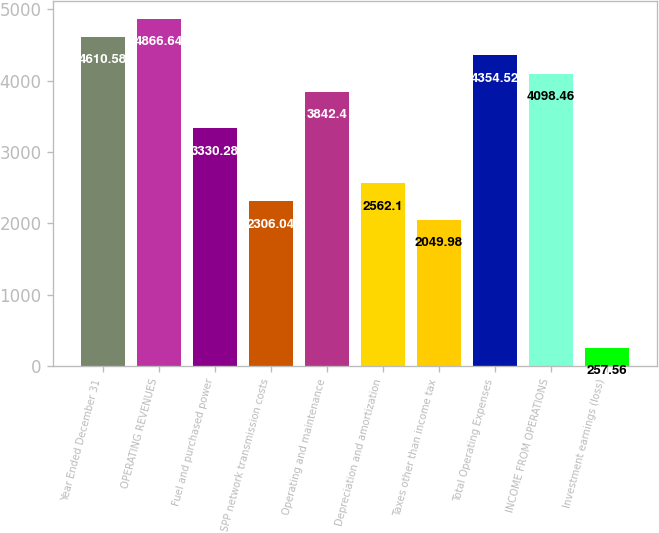Convert chart. <chart><loc_0><loc_0><loc_500><loc_500><bar_chart><fcel>Year Ended December 31<fcel>OPERATING REVENUES<fcel>Fuel and purchased power<fcel>SPP network transmission costs<fcel>Operating and maintenance<fcel>Depreciation and amortization<fcel>Taxes other than income tax<fcel>Total Operating Expenses<fcel>INCOME FROM OPERATIONS<fcel>Investment earnings (loss)<nl><fcel>4610.58<fcel>4866.64<fcel>3330.28<fcel>2306.04<fcel>3842.4<fcel>2562.1<fcel>2049.98<fcel>4354.52<fcel>4098.46<fcel>257.56<nl></chart> 